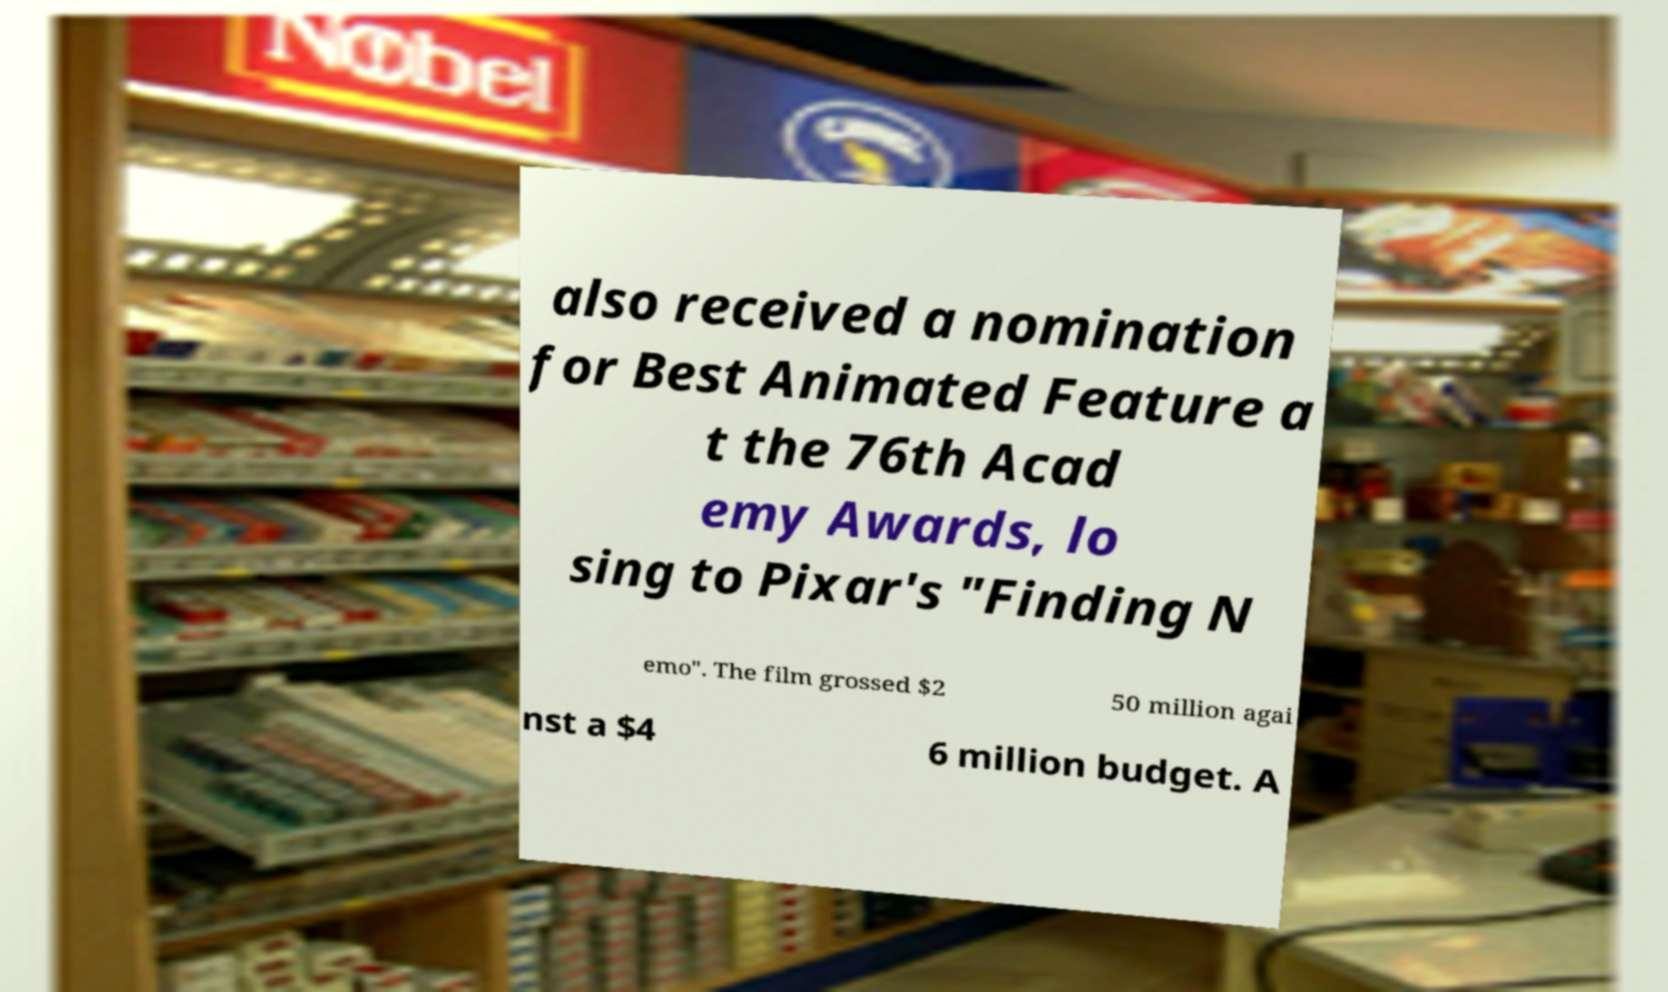There's text embedded in this image that I need extracted. Can you transcribe it verbatim? also received a nomination for Best Animated Feature a t the 76th Acad emy Awards, lo sing to Pixar's "Finding N emo". The film grossed $2 50 million agai nst a $4 6 million budget. A 